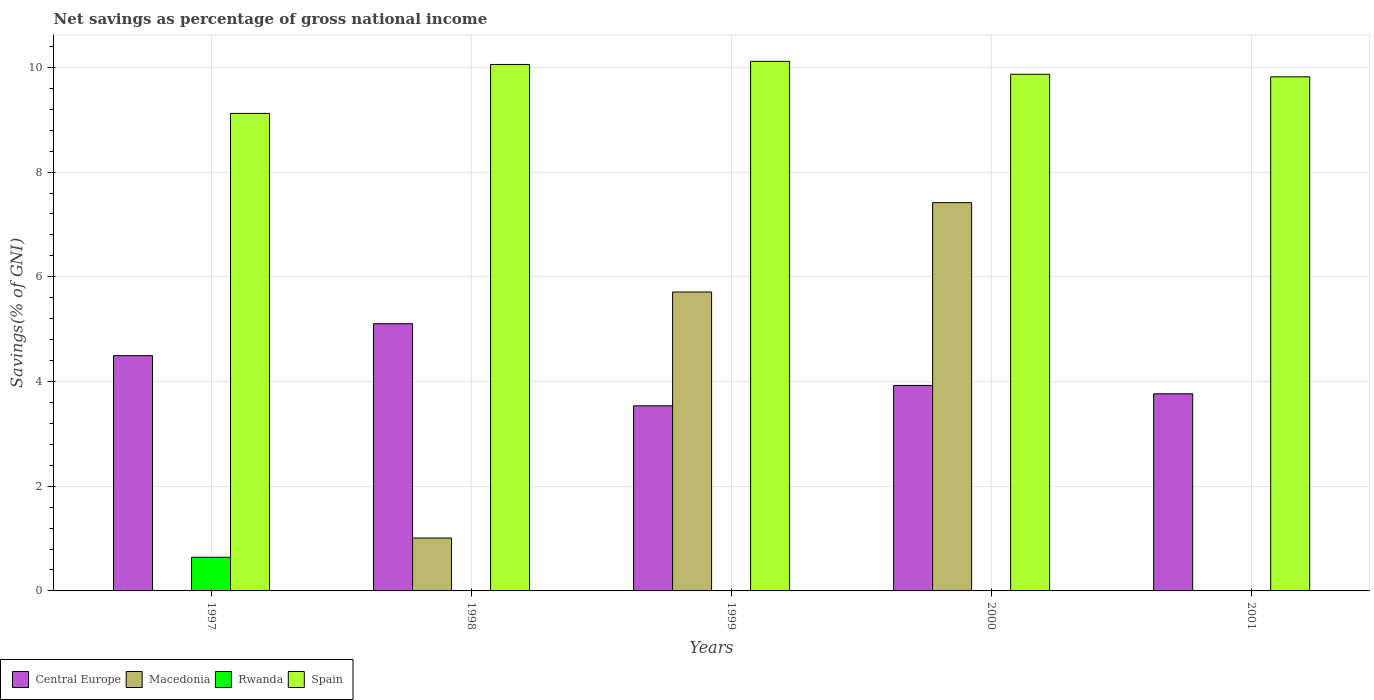Are the number of bars per tick equal to the number of legend labels?
Your response must be concise. No. What is the total savings in Central Europe in 1997?
Make the answer very short. 4.49. Across all years, what is the maximum total savings in Central Europe?
Provide a short and direct response. 5.1. What is the total total savings in Rwanda in the graph?
Your answer should be very brief. 0.64. What is the difference between the total savings in Central Europe in 1999 and that in 2000?
Give a very brief answer. -0.39. What is the difference between the total savings in Macedonia in 2001 and the total savings in Spain in 1999?
Provide a succinct answer. -10.12. What is the average total savings in Central Europe per year?
Offer a very short reply. 4.16. In the year 2000, what is the difference between the total savings in Macedonia and total savings in Central Europe?
Offer a terse response. 3.49. In how many years, is the total savings in Macedonia greater than 6.8 %?
Your answer should be very brief. 1. What is the ratio of the total savings in Spain in 1998 to that in 2001?
Make the answer very short. 1.02. Is the total savings in Spain in 1999 less than that in 2000?
Make the answer very short. No. Is the difference between the total savings in Macedonia in 1998 and 2000 greater than the difference between the total savings in Central Europe in 1998 and 2000?
Your answer should be very brief. No. What is the difference between the highest and the second highest total savings in Spain?
Provide a short and direct response. 0.06. What is the difference between the highest and the lowest total savings in Macedonia?
Your response must be concise. 7.42. Is the sum of the total savings in Central Europe in 1999 and 2000 greater than the maximum total savings in Rwanda across all years?
Your answer should be very brief. Yes. Is it the case that in every year, the sum of the total savings in Rwanda and total savings in Central Europe is greater than the total savings in Spain?
Give a very brief answer. No. Are all the bars in the graph horizontal?
Ensure brevity in your answer.  No. Does the graph contain grids?
Offer a very short reply. Yes. How are the legend labels stacked?
Make the answer very short. Horizontal. What is the title of the graph?
Provide a short and direct response. Net savings as percentage of gross national income. What is the label or title of the X-axis?
Give a very brief answer. Years. What is the label or title of the Y-axis?
Give a very brief answer. Savings(% of GNI). What is the Savings(% of GNI) of Central Europe in 1997?
Provide a succinct answer. 4.49. What is the Savings(% of GNI) in Rwanda in 1997?
Give a very brief answer. 0.64. What is the Savings(% of GNI) in Spain in 1997?
Offer a terse response. 9.12. What is the Savings(% of GNI) of Central Europe in 1998?
Give a very brief answer. 5.1. What is the Savings(% of GNI) of Macedonia in 1998?
Provide a succinct answer. 1.01. What is the Savings(% of GNI) in Rwanda in 1998?
Provide a succinct answer. 0. What is the Savings(% of GNI) of Spain in 1998?
Your response must be concise. 10.06. What is the Savings(% of GNI) of Central Europe in 1999?
Offer a terse response. 3.54. What is the Savings(% of GNI) of Macedonia in 1999?
Make the answer very short. 5.71. What is the Savings(% of GNI) of Spain in 1999?
Provide a succinct answer. 10.12. What is the Savings(% of GNI) in Central Europe in 2000?
Provide a succinct answer. 3.92. What is the Savings(% of GNI) of Macedonia in 2000?
Provide a short and direct response. 7.42. What is the Savings(% of GNI) in Spain in 2000?
Offer a terse response. 9.87. What is the Savings(% of GNI) of Central Europe in 2001?
Ensure brevity in your answer.  3.77. What is the Savings(% of GNI) of Macedonia in 2001?
Your answer should be very brief. 0. What is the Savings(% of GNI) in Spain in 2001?
Provide a succinct answer. 9.82. Across all years, what is the maximum Savings(% of GNI) of Central Europe?
Offer a terse response. 5.1. Across all years, what is the maximum Savings(% of GNI) in Macedonia?
Offer a very short reply. 7.42. Across all years, what is the maximum Savings(% of GNI) of Rwanda?
Your response must be concise. 0.64. Across all years, what is the maximum Savings(% of GNI) of Spain?
Your answer should be very brief. 10.12. Across all years, what is the minimum Savings(% of GNI) in Central Europe?
Provide a succinct answer. 3.54. Across all years, what is the minimum Savings(% of GNI) of Spain?
Provide a short and direct response. 9.12. What is the total Savings(% of GNI) in Central Europe in the graph?
Provide a succinct answer. 20.82. What is the total Savings(% of GNI) in Macedonia in the graph?
Provide a succinct answer. 14.14. What is the total Savings(% of GNI) in Rwanda in the graph?
Keep it short and to the point. 0.64. What is the total Savings(% of GNI) of Spain in the graph?
Offer a terse response. 48.98. What is the difference between the Savings(% of GNI) of Central Europe in 1997 and that in 1998?
Ensure brevity in your answer.  -0.61. What is the difference between the Savings(% of GNI) in Spain in 1997 and that in 1998?
Give a very brief answer. -0.93. What is the difference between the Savings(% of GNI) of Central Europe in 1997 and that in 1999?
Ensure brevity in your answer.  0.96. What is the difference between the Savings(% of GNI) in Spain in 1997 and that in 1999?
Your answer should be very brief. -0.99. What is the difference between the Savings(% of GNI) in Central Europe in 1997 and that in 2000?
Keep it short and to the point. 0.57. What is the difference between the Savings(% of GNI) in Spain in 1997 and that in 2000?
Make the answer very short. -0.75. What is the difference between the Savings(% of GNI) in Central Europe in 1997 and that in 2001?
Provide a succinct answer. 0.73. What is the difference between the Savings(% of GNI) of Spain in 1997 and that in 2001?
Keep it short and to the point. -0.7. What is the difference between the Savings(% of GNI) of Central Europe in 1998 and that in 1999?
Provide a succinct answer. 1.57. What is the difference between the Savings(% of GNI) in Macedonia in 1998 and that in 1999?
Provide a short and direct response. -4.7. What is the difference between the Savings(% of GNI) in Spain in 1998 and that in 1999?
Offer a terse response. -0.06. What is the difference between the Savings(% of GNI) of Central Europe in 1998 and that in 2000?
Offer a very short reply. 1.18. What is the difference between the Savings(% of GNI) of Macedonia in 1998 and that in 2000?
Offer a very short reply. -6.41. What is the difference between the Savings(% of GNI) in Spain in 1998 and that in 2000?
Provide a succinct answer. 0.19. What is the difference between the Savings(% of GNI) in Central Europe in 1998 and that in 2001?
Offer a very short reply. 1.34. What is the difference between the Savings(% of GNI) of Spain in 1998 and that in 2001?
Your response must be concise. 0.24. What is the difference between the Savings(% of GNI) in Central Europe in 1999 and that in 2000?
Your answer should be compact. -0.39. What is the difference between the Savings(% of GNI) of Macedonia in 1999 and that in 2000?
Offer a terse response. -1.71. What is the difference between the Savings(% of GNI) in Spain in 1999 and that in 2000?
Your response must be concise. 0.25. What is the difference between the Savings(% of GNI) of Central Europe in 1999 and that in 2001?
Your response must be concise. -0.23. What is the difference between the Savings(% of GNI) of Spain in 1999 and that in 2001?
Your answer should be compact. 0.3. What is the difference between the Savings(% of GNI) of Central Europe in 2000 and that in 2001?
Your answer should be very brief. 0.16. What is the difference between the Savings(% of GNI) in Spain in 2000 and that in 2001?
Offer a terse response. 0.05. What is the difference between the Savings(% of GNI) in Central Europe in 1997 and the Savings(% of GNI) in Macedonia in 1998?
Offer a terse response. 3.48. What is the difference between the Savings(% of GNI) of Central Europe in 1997 and the Savings(% of GNI) of Spain in 1998?
Your answer should be compact. -5.56. What is the difference between the Savings(% of GNI) of Rwanda in 1997 and the Savings(% of GNI) of Spain in 1998?
Offer a terse response. -9.41. What is the difference between the Savings(% of GNI) of Central Europe in 1997 and the Savings(% of GNI) of Macedonia in 1999?
Give a very brief answer. -1.22. What is the difference between the Savings(% of GNI) of Central Europe in 1997 and the Savings(% of GNI) of Spain in 1999?
Offer a terse response. -5.62. What is the difference between the Savings(% of GNI) of Rwanda in 1997 and the Savings(% of GNI) of Spain in 1999?
Provide a short and direct response. -9.47. What is the difference between the Savings(% of GNI) in Central Europe in 1997 and the Savings(% of GNI) in Macedonia in 2000?
Offer a terse response. -2.92. What is the difference between the Savings(% of GNI) in Central Europe in 1997 and the Savings(% of GNI) in Spain in 2000?
Make the answer very short. -5.38. What is the difference between the Savings(% of GNI) of Rwanda in 1997 and the Savings(% of GNI) of Spain in 2000?
Offer a terse response. -9.23. What is the difference between the Savings(% of GNI) in Central Europe in 1997 and the Savings(% of GNI) in Spain in 2001?
Provide a short and direct response. -5.33. What is the difference between the Savings(% of GNI) in Rwanda in 1997 and the Savings(% of GNI) in Spain in 2001?
Give a very brief answer. -9.18. What is the difference between the Savings(% of GNI) of Central Europe in 1998 and the Savings(% of GNI) of Macedonia in 1999?
Your answer should be compact. -0.61. What is the difference between the Savings(% of GNI) of Central Europe in 1998 and the Savings(% of GNI) of Spain in 1999?
Make the answer very short. -5.01. What is the difference between the Savings(% of GNI) in Macedonia in 1998 and the Savings(% of GNI) in Spain in 1999?
Provide a short and direct response. -9.1. What is the difference between the Savings(% of GNI) of Central Europe in 1998 and the Savings(% of GNI) of Macedonia in 2000?
Provide a short and direct response. -2.31. What is the difference between the Savings(% of GNI) of Central Europe in 1998 and the Savings(% of GNI) of Spain in 2000?
Make the answer very short. -4.76. What is the difference between the Savings(% of GNI) of Macedonia in 1998 and the Savings(% of GNI) of Spain in 2000?
Provide a succinct answer. -8.86. What is the difference between the Savings(% of GNI) of Central Europe in 1998 and the Savings(% of GNI) of Spain in 2001?
Your response must be concise. -4.72. What is the difference between the Savings(% of GNI) in Macedonia in 1998 and the Savings(% of GNI) in Spain in 2001?
Provide a succinct answer. -8.81. What is the difference between the Savings(% of GNI) of Central Europe in 1999 and the Savings(% of GNI) of Macedonia in 2000?
Offer a terse response. -3.88. What is the difference between the Savings(% of GNI) of Central Europe in 1999 and the Savings(% of GNI) of Spain in 2000?
Offer a very short reply. -6.33. What is the difference between the Savings(% of GNI) in Macedonia in 1999 and the Savings(% of GNI) in Spain in 2000?
Your answer should be very brief. -4.16. What is the difference between the Savings(% of GNI) of Central Europe in 1999 and the Savings(% of GNI) of Spain in 2001?
Make the answer very short. -6.28. What is the difference between the Savings(% of GNI) of Macedonia in 1999 and the Savings(% of GNI) of Spain in 2001?
Your answer should be compact. -4.11. What is the difference between the Savings(% of GNI) in Central Europe in 2000 and the Savings(% of GNI) in Spain in 2001?
Your answer should be compact. -5.89. What is the difference between the Savings(% of GNI) of Macedonia in 2000 and the Savings(% of GNI) of Spain in 2001?
Provide a short and direct response. -2.4. What is the average Savings(% of GNI) of Central Europe per year?
Make the answer very short. 4.16. What is the average Savings(% of GNI) of Macedonia per year?
Make the answer very short. 2.83. What is the average Savings(% of GNI) of Rwanda per year?
Your answer should be very brief. 0.13. What is the average Savings(% of GNI) of Spain per year?
Provide a short and direct response. 9.8. In the year 1997, what is the difference between the Savings(% of GNI) of Central Europe and Savings(% of GNI) of Rwanda?
Your response must be concise. 3.85. In the year 1997, what is the difference between the Savings(% of GNI) in Central Europe and Savings(% of GNI) in Spain?
Offer a very short reply. -4.63. In the year 1997, what is the difference between the Savings(% of GNI) of Rwanda and Savings(% of GNI) of Spain?
Ensure brevity in your answer.  -8.48. In the year 1998, what is the difference between the Savings(% of GNI) in Central Europe and Savings(% of GNI) in Macedonia?
Offer a very short reply. 4.09. In the year 1998, what is the difference between the Savings(% of GNI) of Central Europe and Savings(% of GNI) of Spain?
Your answer should be compact. -4.95. In the year 1998, what is the difference between the Savings(% of GNI) in Macedonia and Savings(% of GNI) in Spain?
Provide a short and direct response. -9.04. In the year 1999, what is the difference between the Savings(% of GNI) of Central Europe and Savings(% of GNI) of Macedonia?
Your answer should be very brief. -2.17. In the year 1999, what is the difference between the Savings(% of GNI) of Central Europe and Savings(% of GNI) of Spain?
Your answer should be very brief. -6.58. In the year 1999, what is the difference between the Savings(% of GNI) in Macedonia and Savings(% of GNI) in Spain?
Offer a terse response. -4.41. In the year 2000, what is the difference between the Savings(% of GNI) in Central Europe and Savings(% of GNI) in Macedonia?
Provide a succinct answer. -3.49. In the year 2000, what is the difference between the Savings(% of GNI) of Central Europe and Savings(% of GNI) of Spain?
Make the answer very short. -5.94. In the year 2000, what is the difference between the Savings(% of GNI) of Macedonia and Savings(% of GNI) of Spain?
Your answer should be very brief. -2.45. In the year 2001, what is the difference between the Savings(% of GNI) in Central Europe and Savings(% of GNI) in Spain?
Your answer should be compact. -6.05. What is the ratio of the Savings(% of GNI) of Central Europe in 1997 to that in 1998?
Your answer should be very brief. 0.88. What is the ratio of the Savings(% of GNI) of Spain in 1997 to that in 1998?
Your response must be concise. 0.91. What is the ratio of the Savings(% of GNI) in Central Europe in 1997 to that in 1999?
Keep it short and to the point. 1.27. What is the ratio of the Savings(% of GNI) in Spain in 1997 to that in 1999?
Give a very brief answer. 0.9. What is the ratio of the Savings(% of GNI) in Central Europe in 1997 to that in 2000?
Keep it short and to the point. 1.14. What is the ratio of the Savings(% of GNI) of Spain in 1997 to that in 2000?
Your answer should be very brief. 0.92. What is the ratio of the Savings(% of GNI) in Central Europe in 1997 to that in 2001?
Give a very brief answer. 1.19. What is the ratio of the Savings(% of GNI) in Spain in 1997 to that in 2001?
Make the answer very short. 0.93. What is the ratio of the Savings(% of GNI) of Central Europe in 1998 to that in 1999?
Your response must be concise. 1.44. What is the ratio of the Savings(% of GNI) in Macedonia in 1998 to that in 1999?
Offer a very short reply. 0.18. What is the ratio of the Savings(% of GNI) of Central Europe in 1998 to that in 2000?
Provide a succinct answer. 1.3. What is the ratio of the Savings(% of GNI) in Macedonia in 1998 to that in 2000?
Ensure brevity in your answer.  0.14. What is the ratio of the Savings(% of GNI) in Central Europe in 1998 to that in 2001?
Your response must be concise. 1.36. What is the ratio of the Savings(% of GNI) of Spain in 1998 to that in 2001?
Your response must be concise. 1.02. What is the ratio of the Savings(% of GNI) of Central Europe in 1999 to that in 2000?
Offer a very short reply. 0.9. What is the ratio of the Savings(% of GNI) in Macedonia in 1999 to that in 2000?
Your response must be concise. 0.77. What is the ratio of the Savings(% of GNI) in Spain in 1999 to that in 2000?
Make the answer very short. 1.02. What is the ratio of the Savings(% of GNI) of Central Europe in 1999 to that in 2001?
Give a very brief answer. 0.94. What is the ratio of the Savings(% of GNI) of Spain in 1999 to that in 2001?
Make the answer very short. 1.03. What is the ratio of the Savings(% of GNI) in Central Europe in 2000 to that in 2001?
Your answer should be very brief. 1.04. What is the difference between the highest and the second highest Savings(% of GNI) of Central Europe?
Provide a succinct answer. 0.61. What is the difference between the highest and the second highest Savings(% of GNI) in Macedonia?
Make the answer very short. 1.71. What is the difference between the highest and the second highest Savings(% of GNI) in Spain?
Your response must be concise. 0.06. What is the difference between the highest and the lowest Savings(% of GNI) of Central Europe?
Make the answer very short. 1.57. What is the difference between the highest and the lowest Savings(% of GNI) of Macedonia?
Ensure brevity in your answer.  7.42. What is the difference between the highest and the lowest Savings(% of GNI) in Rwanda?
Provide a succinct answer. 0.64. 